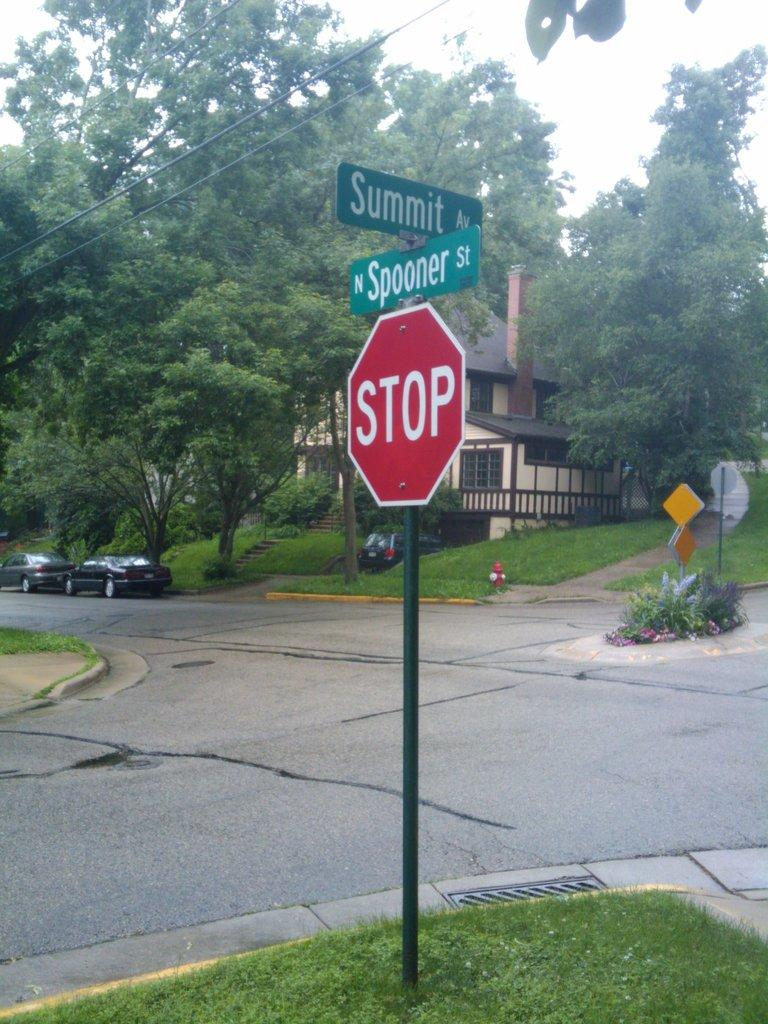<image>
Relay a brief, clear account of the picture shown. A stop sign is located at the intersection of Summit Ave and Spooner street. 